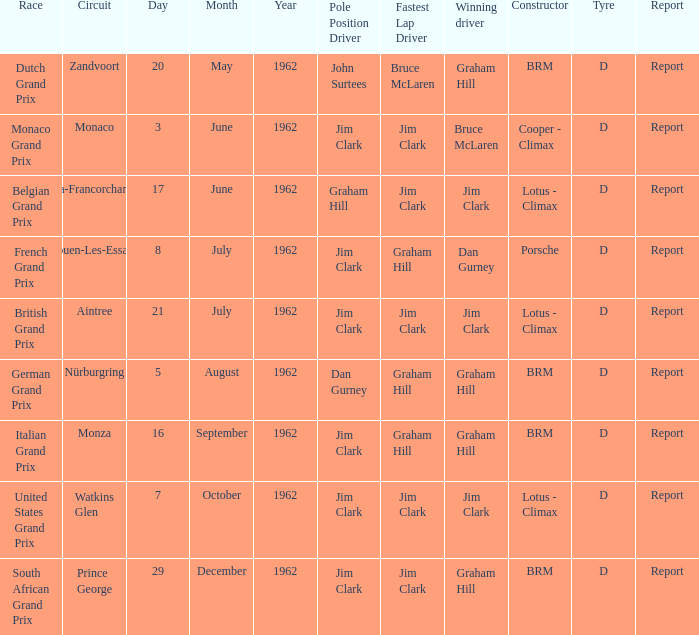What is the tyre for the circuit of Prince George, which had Jim Clark as the fastest lap? D. 